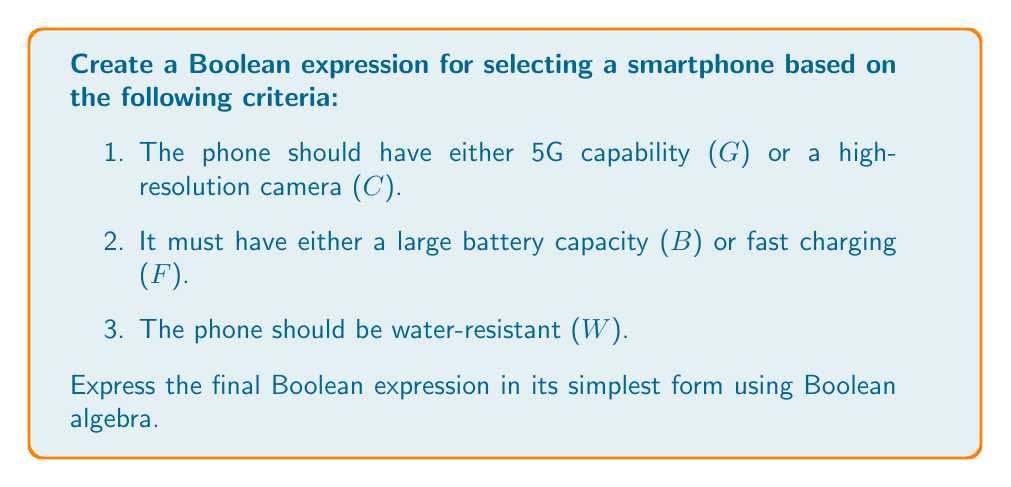Can you answer this question? Let's approach this step-by-step:

1) First, let's translate each criterion into a Boolean expression:
   a) $G + C$ (5G or high-resolution camera)
   b) $B + F$ (large battery or fast charging)
   c) $W$ (water-resistant)

2) To satisfy all criteria, we need to AND these expressions:
   $$(G + C) \cdot (B + F) \cdot W$$

3) Now, let's expand this expression using the distributive property:
   $$(G \cdot B \cdot W) + (G \cdot F \cdot W) + (C \cdot B \cdot W) + (C \cdot F \cdot W)$$

4) We can factor out W since it's common to all terms:
   $$W \cdot (G \cdot B + G \cdot F + C \cdot B + C \cdot F)$$

5) Inside the parentheses, we can factor out G and C:
   $$W \cdot (G \cdot (B + F) + C \cdot (B + F))$$

6) We can factor out $(B + F)$ from both terms:
   $$W \cdot (B + F) \cdot (G + C)$$

This is the simplest form of the Boolean expression, representing a decision tree where:
- The phone must be water-resistant (W), AND
- It must have either a large battery or fast charging (B + F), AND
- It must have either 5G capability or a high-resolution camera (G + C).
Answer: $W \cdot (B + F) \cdot (G + C)$ 